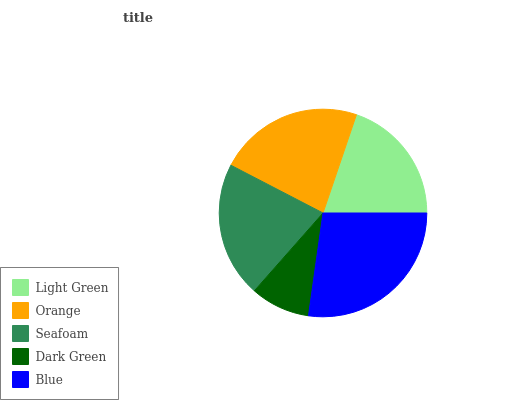Is Dark Green the minimum?
Answer yes or no. Yes. Is Blue the maximum?
Answer yes or no. Yes. Is Orange the minimum?
Answer yes or no. No. Is Orange the maximum?
Answer yes or no. No. Is Orange greater than Light Green?
Answer yes or no. Yes. Is Light Green less than Orange?
Answer yes or no. Yes. Is Light Green greater than Orange?
Answer yes or no. No. Is Orange less than Light Green?
Answer yes or no. No. Is Seafoam the high median?
Answer yes or no. Yes. Is Seafoam the low median?
Answer yes or no. Yes. Is Orange the high median?
Answer yes or no. No. Is Dark Green the low median?
Answer yes or no. No. 